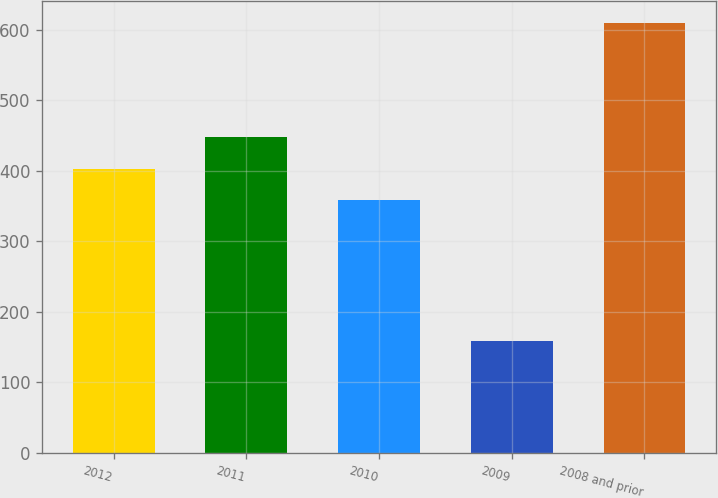Convert chart to OTSL. <chart><loc_0><loc_0><loc_500><loc_500><bar_chart><fcel>2012<fcel>2011<fcel>2010<fcel>2009<fcel>2008 and prior<nl><fcel>403.1<fcel>448.2<fcel>358<fcel>159<fcel>610<nl></chart> 